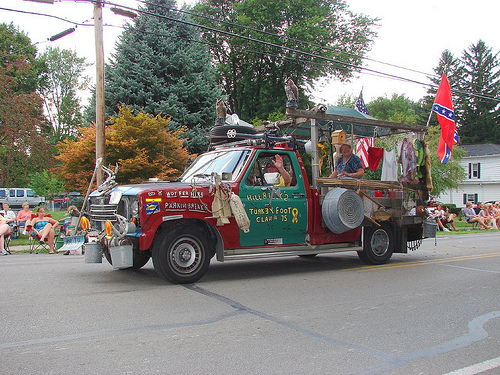<image>
Can you confirm if the female is under the truck? No. The female is not positioned under the truck. The vertical relationship between these objects is different. 